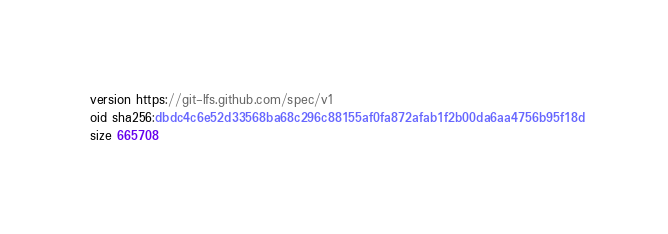Convert code to text. <code><loc_0><loc_0><loc_500><loc_500><_TypeScript_>version https://git-lfs.github.com/spec/v1
oid sha256:dbdc4c6e52d33568ba68c296c88155af0fa872afab1f2b00da6aa4756b95f18d
size 665708
</code> 